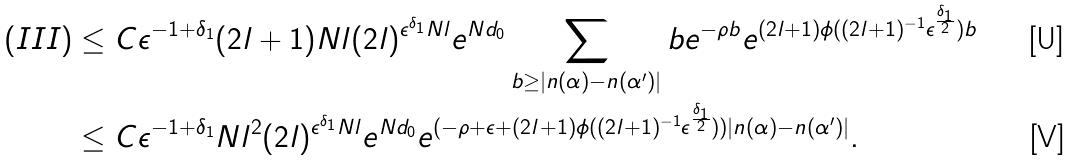Convert formula to latex. <formula><loc_0><loc_0><loc_500><loc_500>( I I I ) \leq & \ C \epsilon ^ { - 1 + \delta _ { 1 } } ( 2 l + 1 ) N l ( 2 l ) ^ { \epsilon ^ { \delta _ { 1 } } N l } e ^ { N d _ { 0 } } \sum _ { b \geq | n ( \alpha ) - n ( \alpha ^ { \prime } ) | } b e ^ { - \rho b } e ^ { ( 2 l + 1 ) \phi ( ( 2 l + 1 ) ^ { - 1 } \epsilon ^ { \frac { \delta _ { 1 } } { 2 } } ) b } \\ \leq & \ C \epsilon ^ { - 1 + \delta _ { 1 } } N l ^ { 2 } ( 2 l ) ^ { \epsilon ^ { \delta _ { 1 } } N l } e ^ { N d _ { 0 } } e ^ { ( - \rho + \epsilon + ( 2 l + 1 ) \phi ( ( 2 l + 1 ) ^ { - 1 } \epsilon ^ { \frac { \delta _ { 1 } } { 2 } } ) ) | n ( \alpha ) - n ( \alpha ^ { \prime } ) | } .</formula> 